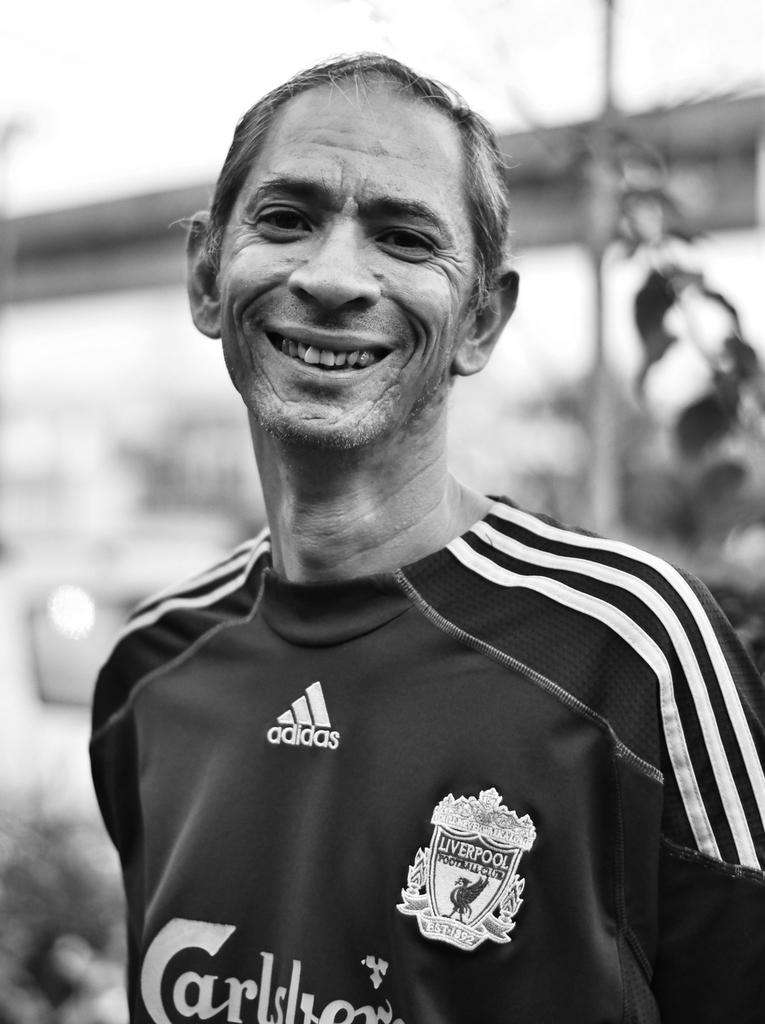<image>
Provide a brief description of the given image. A man in an Adidas athletic shirt with a Liverpool Football Club badge is smiling. 